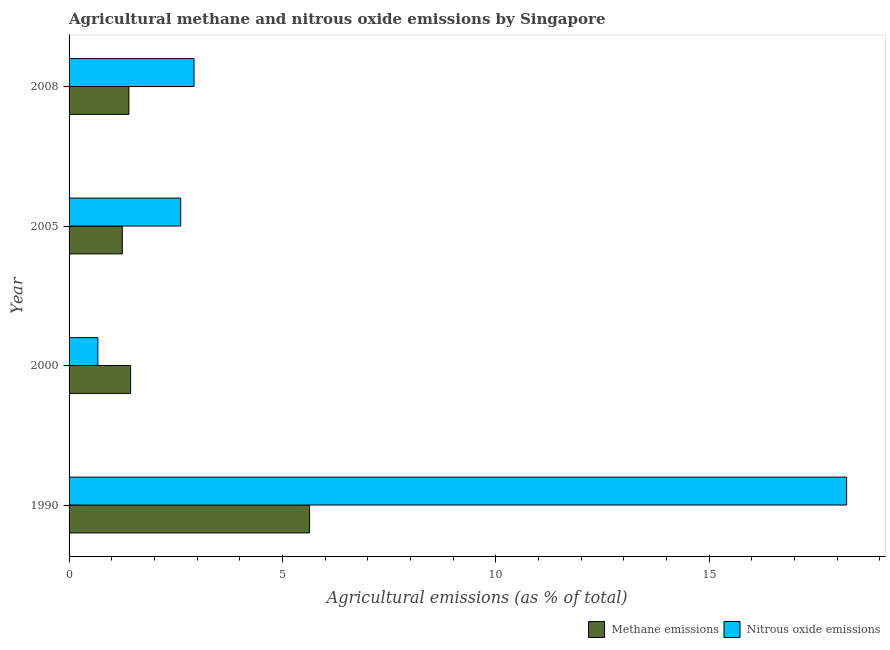Are the number of bars per tick equal to the number of legend labels?
Your answer should be compact. Yes. In how many cases, is the number of bars for a given year not equal to the number of legend labels?
Your answer should be very brief. 0. What is the amount of methane emissions in 2008?
Keep it short and to the point. 1.4. Across all years, what is the maximum amount of methane emissions?
Provide a succinct answer. 5.63. Across all years, what is the minimum amount of nitrous oxide emissions?
Your answer should be compact. 0.67. In which year was the amount of methane emissions maximum?
Ensure brevity in your answer.  1990. What is the total amount of methane emissions in the graph?
Give a very brief answer. 9.73. What is the difference between the amount of methane emissions in 2000 and that in 2005?
Your answer should be very brief. 0.2. What is the difference between the amount of methane emissions in 2008 and the amount of nitrous oxide emissions in 1990?
Give a very brief answer. -16.82. What is the average amount of nitrous oxide emissions per year?
Offer a terse response. 6.11. In the year 1990, what is the difference between the amount of methane emissions and amount of nitrous oxide emissions?
Offer a terse response. -12.59. What is the ratio of the amount of methane emissions in 2000 to that in 2005?
Make the answer very short. 1.16. Is the difference between the amount of methane emissions in 2000 and 2005 greater than the difference between the amount of nitrous oxide emissions in 2000 and 2005?
Keep it short and to the point. Yes. What is the difference between the highest and the second highest amount of nitrous oxide emissions?
Give a very brief answer. 15.29. What is the difference between the highest and the lowest amount of methane emissions?
Ensure brevity in your answer.  4.39. Is the sum of the amount of nitrous oxide emissions in 1990 and 2000 greater than the maximum amount of methane emissions across all years?
Make the answer very short. Yes. What does the 1st bar from the top in 2000 represents?
Your answer should be very brief. Nitrous oxide emissions. What does the 2nd bar from the bottom in 2005 represents?
Provide a succinct answer. Nitrous oxide emissions. Are all the bars in the graph horizontal?
Offer a very short reply. Yes. Does the graph contain any zero values?
Keep it short and to the point. No. Where does the legend appear in the graph?
Your answer should be very brief. Bottom right. How are the legend labels stacked?
Offer a very short reply. Horizontal. What is the title of the graph?
Your answer should be very brief. Agricultural methane and nitrous oxide emissions by Singapore. Does "Residents" appear as one of the legend labels in the graph?
Offer a very short reply. No. What is the label or title of the X-axis?
Give a very brief answer. Agricultural emissions (as % of total). What is the Agricultural emissions (as % of total) in Methane emissions in 1990?
Provide a succinct answer. 5.63. What is the Agricultural emissions (as % of total) of Nitrous oxide emissions in 1990?
Provide a short and direct response. 18.22. What is the Agricultural emissions (as % of total) in Methane emissions in 2000?
Provide a succinct answer. 1.44. What is the Agricultural emissions (as % of total) in Nitrous oxide emissions in 2000?
Keep it short and to the point. 0.67. What is the Agricultural emissions (as % of total) in Methane emissions in 2005?
Your answer should be compact. 1.25. What is the Agricultural emissions (as % of total) of Nitrous oxide emissions in 2005?
Make the answer very short. 2.62. What is the Agricultural emissions (as % of total) in Methane emissions in 2008?
Ensure brevity in your answer.  1.4. What is the Agricultural emissions (as % of total) of Nitrous oxide emissions in 2008?
Make the answer very short. 2.93. Across all years, what is the maximum Agricultural emissions (as % of total) in Methane emissions?
Offer a very short reply. 5.63. Across all years, what is the maximum Agricultural emissions (as % of total) of Nitrous oxide emissions?
Offer a very short reply. 18.22. Across all years, what is the minimum Agricultural emissions (as % of total) of Methane emissions?
Offer a terse response. 1.25. Across all years, what is the minimum Agricultural emissions (as % of total) of Nitrous oxide emissions?
Give a very brief answer. 0.67. What is the total Agricultural emissions (as % of total) of Methane emissions in the graph?
Your response must be concise. 9.73. What is the total Agricultural emissions (as % of total) of Nitrous oxide emissions in the graph?
Your response must be concise. 24.44. What is the difference between the Agricultural emissions (as % of total) in Methane emissions in 1990 and that in 2000?
Make the answer very short. 4.19. What is the difference between the Agricultural emissions (as % of total) of Nitrous oxide emissions in 1990 and that in 2000?
Keep it short and to the point. 17.55. What is the difference between the Agricultural emissions (as % of total) of Methane emissions in 1990 and that in 2005?
Keep it short and to the point. 4.39. What is the difference between the Agricultural emissions (as % of total) of Nitrous oxide emissions in 1990 and that in 2005?
Provide a short and direct response. 15.6. What is the difference between the Agricultural emissions (as % of total) of Methane emissions in 1990 and that in 2008?
Your response must be concise. 4.23. What is the difference between the Agricultural emissions (as % of total) of Nitrous oxide emissions in 1990 and that in 2008?
Give a very brief answer. 15.29. What is the difference between the Agricultural emissions (as % of total) of Methane emissions in 2000 and that in 2005?
Provide a short and direct response. 0.2. What is the difference between the Agricultural emissions (as % of total) of Nitrous oxide emissions in 2000 and that in 2005?
Offer a terse response. -1.94. What is the difference between the Agricultural emissions (as % of total) in Methane emissions in 2000 and that in 2008?
Your answer should be compact. 0.04. What is the difference between the Agricultural emissions (as % of total) of Nitrous oxide emissions in 2000 and that in 2008?
Your answer should be compact. -2.25. What is the difference between the Agricultural emissions (as % of total) of Methane emissions in 2005 and that in 2008?
Provide a succinct answer. -0.15. What is the difference between the Agricultural emissions (as % of total) in Nitrous oxide emissions in 2005 and that in 2008?
Offer a terse response. -0.31. What is the difference between the Agricultural emissions (as % of total) of Methane emissions in 1990 and the Agricultural emissions (as % of total) of Nitrous oxide emissions in 2000?
Offer a terse response. 4.96. What is the difference between the Agricultural emissions (as % of total) of Methane emissions in 1990 and the Agricultural emissions (as % of total) of Nitrous oxide emissions in 2005?
Offer a very short reply. 3.02. What is the difference between the Agricultural emissions (as % of total) of Methane emissions in 1990 and the Agricultural emissions (as % of total) of Nitrous oxide emissions in 2008?
Ensure brevity in your answer.  2.71. What is the difference between the Agricultural emissions (as % of total) of Methane emissions in 2000 and the Agricultural emissions (as % of total) of Nitrous oxide emissions in 2005?
Offer a terse response. -1.17. What is the difference between the Agricultural emissions (as % of total) in Methane emissions in 2000 and the Agricultural emissions (as % of total) in Nitrous oxide emissions in 2008?
Make the answer very short. -1.48. What is the difference between the Agricultural emissions (as % of total) in Methane emissions in 2005 and the Agricultural emissions (as % of total) in Nitrous oxide emissions in 2008?
Offer a very short reply. -1.68. What is the average Agricultural emissions (as % of total) in Methane emissions per year?
Give a very brief answer. 2.43. What is the average Agricultural emissions (as % of total) of Nitrous oxide emissions per year?
Offer a very short reply. 6.11. In the year 1990, what is the difference between the Agricultural emissions (as % of total) of Methane emissions and Agricultural emissions (as % of total) of Nitrous oxide emissions?
Offer a terse response. -12.59. In the year 2000, what is the difference between the Agricultural emissions (as % of total) of Methane emissions and Agricultural emissions (as % of total) of Nitrous oxide emissions?
Make the answer very short. 0.77. In the year 2005, what is the difference between the Agricultural emissions (as % of total) of Methane emissions and Agricultural emissions (as % of total) of Nitrous oxide emissions?
Offer a very short reply. -1.37. In the year 2008, what is the difference between the Agricultural emissions (as % of total) of Methane emissions and Agricultural emissions (as % of total) of Nitrous oxide emissions?
Your response must be concise. -1.53. What is the ratio of the Agricultural emissions (as % of total) of Methane emissions in 1990 to that in 2000?
Keep it short and to the point. 3.9. What is the ratio of the Agricultural emissions (as % of total) in Nitrous oxide emissions in 1990 to that in 2000?
Ensure brevity in your answer.  27.02. What is the ratio of the Agricultural emissions (as % of total) in Methane emissions in 1990 to that in 2005?
Provide a succinct answer. 4.52. What is the ratio of the Agricultural emissions (as % of total) in Nitrous oxide emissions in 1990 to that in 2005?
Offer a very short reply. 6.96. What is the ratio of the Agricultural emissions (as % of total) in Methane emissions in 1990 to that in 2008?
Ensure brevity in your answer.  4.02. What is the ratio of the Agricultural emissions (as % of total) in Nitrous oxide emissions in 1990 to that in 2008?
Your response must be concise. 6.22. What is the ratio of the Agricultural emissions (as % of total) of Methane emissions in 2000 to that in 2005?
Your response must be concise. 1.16. What is the ratio of the Agricultural emissions (as % of total) in Nitrous oxide emissions in 2000 to that in 2005?
Offer a very short reply. 0.26. What is the ratio of the Agricultural emissions (as % of total) in Methane emissions in 2000 to that in 2008?
Your response must be concise. 1.03. What is the ratio of the Agricultural emissions (as % of total) of Nitrous oxide emissions in 2000 to that in 2008?
Make the answer very short. 0.23. What is the ratio of the Agricultural emissions (as % of total) in Methane emissions in 2005 to that in 2008?
Provide a short and direct response. 0.89. What is the ratio of the Agricultural emissions (as % of total) of Nitrous oxide emissions in 2005 to that in 2008?
Ensure brevity in your answer.  0.89. What is the difference between the highest and the second highest Agricultural emissions (as % of total) in Methane emissions?
Provide a succinct answer. 4.19. What is the difference between the highest and the second highest Agricultural emissions (as % of total) of Nitrous oxide emissions?
Make the answer very short. 15.29. What is the difference between the highest and the lowest Agricultural emissions (as % of total) of Methane emissions?
Your response must be concise. 4.39. What is the difference between the highest and the lowest Agricultural emissions (as % of total) of Nitrous oxide emissions?
Offer a terse response. 17.55. 